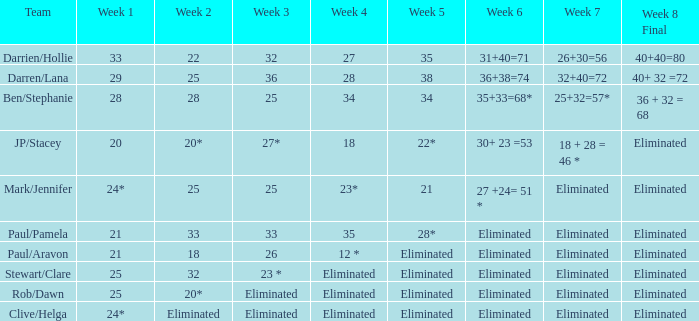Name the week 6 when week 3 is 25 and week 7 is eliminated 27 +24= 51 *. 